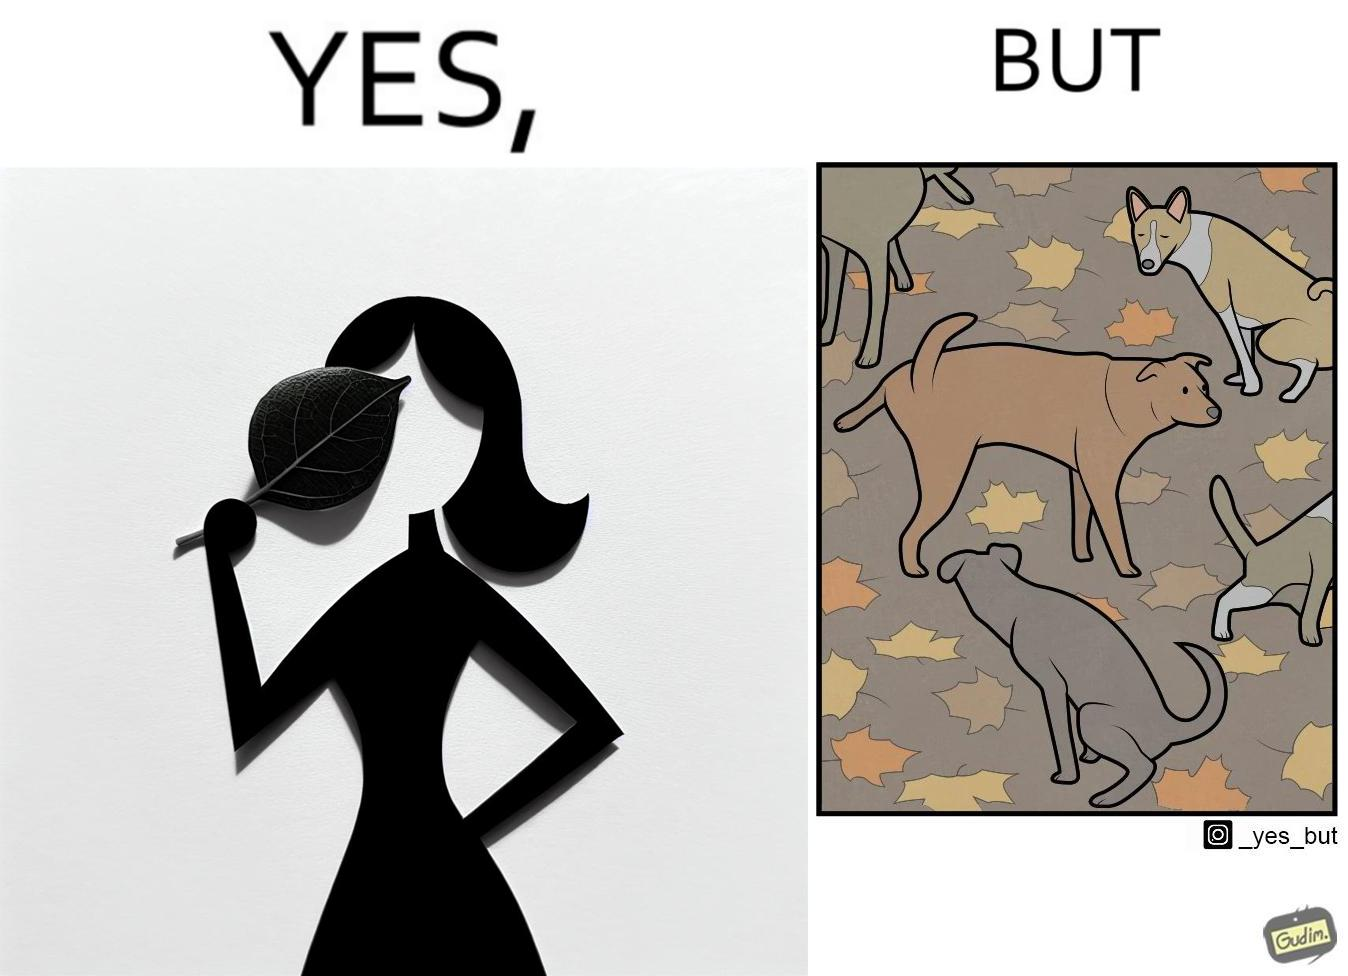Compare the left and right sides of this image. In the left part of the image: It is a woman holding a leaf over half of her face for a good photo In the right part of the image: It is a few dogs defecating and urinating over leaves 